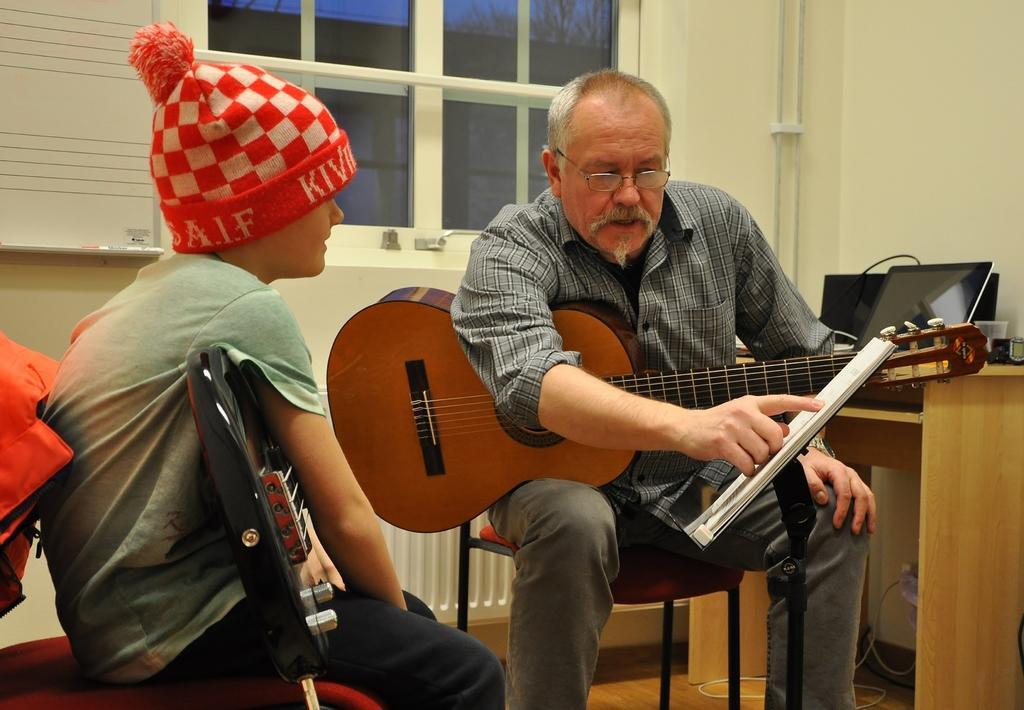Please provide a concise description of this image. In this image there are two persons sitting on the chair. In front the person is holding a guitar at the background there is a window and a wall. On right side there is a laptop on the table. In front there is a book and a stand. 